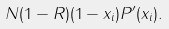<formula> <loc_0><loc_0><loc_500><loc_500>N ( 1 - R ) ( 1 - x _ { i } ) P ^ { \prime } ( x _ { i } ) .</formula> 